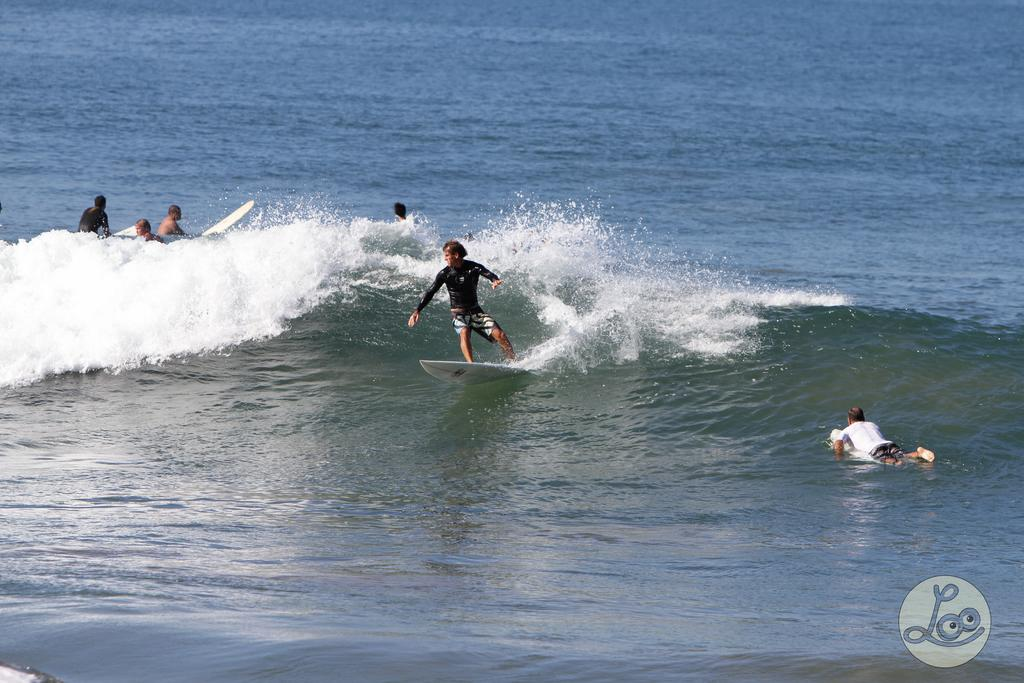What is the main setting of the image? There is an ocean in the image. Are there any people in the image? Yes, people are present in the image. What are the people doing in the image? The people are moving on surfing boards in the ocean. What type of feast is being prepared on the beach in the image? There is no feast or beach present in the image; it features people surfing in the ocean. Can you describe the arch that is supporting the surfers in the image? There is no arch present in the image; the people are surfing on surfing boards in the ocean. 